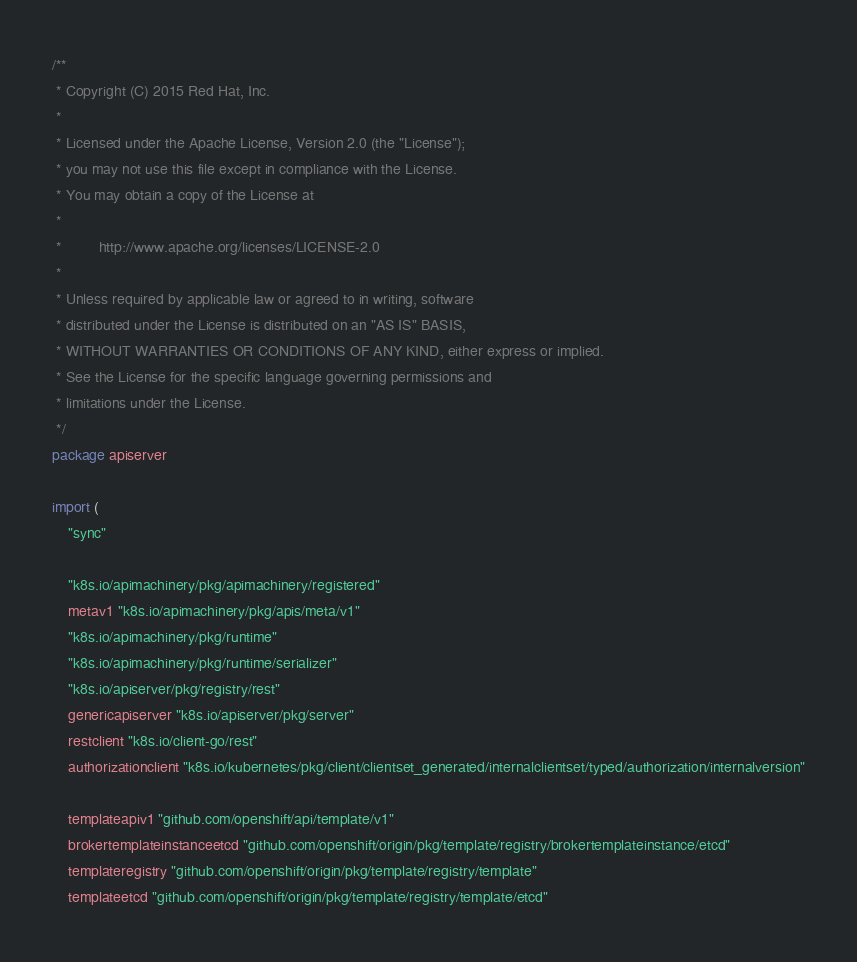<code> <loc_0><loc_0><loc_500><loc_500><_Go_>/**
 * Copyright (C) 2015 Red Hat, Inc.
 *
 * Licensed under the Apache License, Version 2.0 (the "License");
 * you may not use this file except in compliance with the License.
 * You may obtain a copy of the License at
 *
 *         http://www.apache.org/licenses/LICENSE-2.0
 *
 * Unless required by applicable law or agreed to in writing, software
 * distributed under the License is distributed on an "AS IS" BASIS,
 * WITHOUT WARRANTIES OR CONDITIONS OF ANY KIND, either express or implied.
 * See the License for the specific language governing permissions and
 * limitations under the License.
 */
package apiserver

import (
	"sync"

	"k8s.io/apimachinery/pkg/apimachinery/registered"
	metav1 "k8s.io/apimachinery/pkg/apis/meta/v1"
	"k8s.io/apimachinery/pkg/runtime"
	"k8s.io/apimachinery/pkg/runtime/serializer"
	"k8s.io/apiserver/pkg/registry/rest"
	genericapiserver "k8s.io/apiserver/pkg/server"
	restclient "k8s.io/client-go/rest"
	authorizationclient "k8s.io/kubernetes/pkg/client/clientset_generated/internalclientset/typed/authorization/internalversion"

	templateapiv1 "github.com/openshift/api/template/v1"
	brokertemplateinstanceetcd "github.com/openshift/origin/pkg/template/registry/brokertemplateinstance/etcd"
	templateregistry "github.com/openshift/origin/pkg/template/registry/template"
	templateetcd "github.com/openshift/origin/pkg/template/registry/template/etcd"</code> 